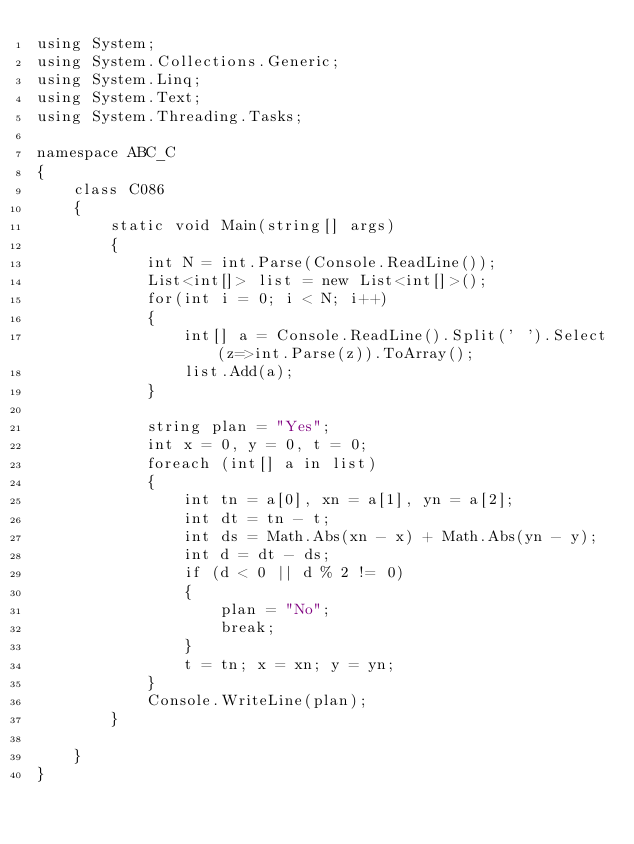Convert code to text. <code><loc_0><loc_0><loc_500><loc_500><_C#_>using System;
using System.Collections.Generic;
using System.Linq;
using System.Text;
using System.Threading.Tasks;

namespace ABC_C
{
    class C086
    {
        static void Main(string[] args)
        {
            int N = int.Parse(Console.ReadLine());
            List<int[]> list = new List<int[]>();
            for(int i = 0; i < N; i++)
            {
                int[] a = Console.ReadLine().Split(' ').Select(z=>int.Parse(z)).ToArray();
                list.Add(a);
            }

            string plan = "Yes";
            int x = 0, y = 0, t = 0;
            foreach (int[] a in list)
            {
                int tn = a[0], xn = a[1], yn = a[2];
                int dt = tn - t;
                int ds = Math.Abs(xn - x) + Math.Abs(yn - y);
                int d = dt - ds;
                if (d < 0 || d % 2 != 0)
                {
                    plan = "No";
                    break;
                }
                t = tn; x = xn; y = yn;
            }
            Console.WriteLine(plan);
        }

    }
}
</code> 